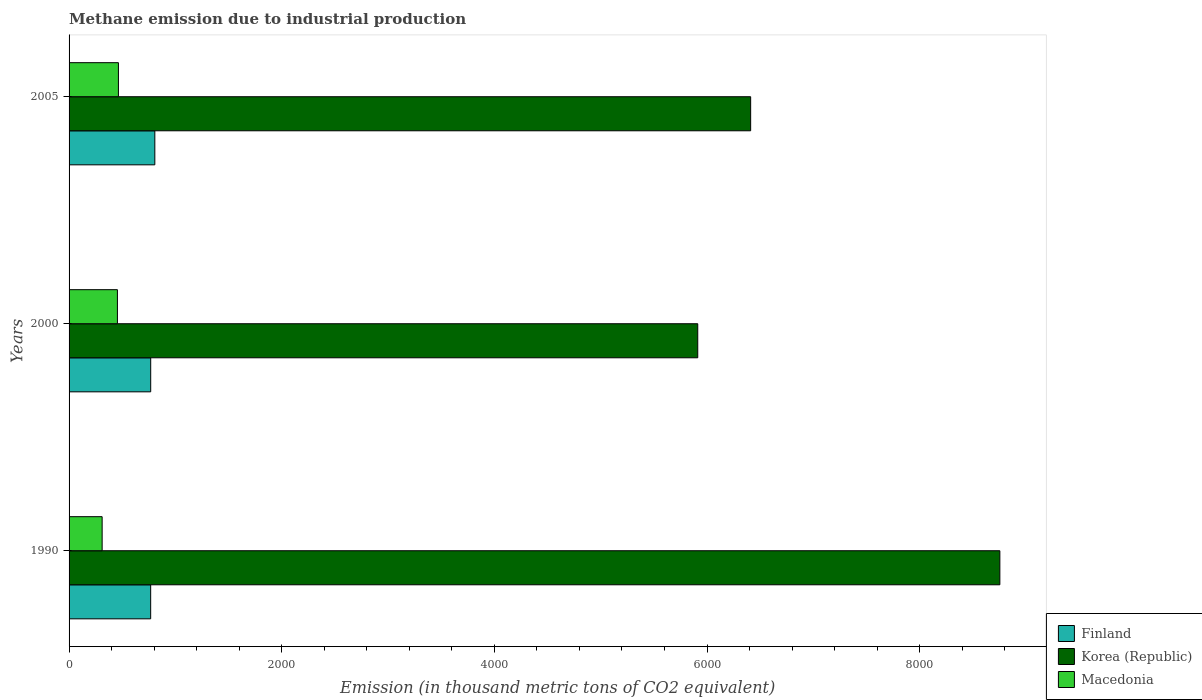How many different coloured bars are there?
Offer a very short reply. 3. Are the number of bars per tick equal to the number of legend labels?
Keep it short and to the point. Yes. Are the number of bars on each tick of the Y-axis equal?
Give a very brief answer. Yes. What is the label of the 3rd group of bars from the top?
Make the answer very short. 1990. In how many cases, is the number of bars for a given year not equal to the number of legend labels?
Offer a terse response. 0. What is the amount of methane emitted in Macedonia in 2005?
Offer a very short reply. 464.2. Across all years, what is the maximum amount of methane emitted in Macedonia?
Make the answer very short. 464.2. Across all years, what is the minimum amount of methane emitted in Korea (Republic)?
Give a very brief answer. 5912.8. What is the total amount of methane emitted in Korea (Republic) in the graph?
Provide a succinct answer. 2.11e+04. What is the difference between the amount of methane emitted in Finland in 2000 and that in 2005?
Give a very brief answer. -38.8. What is the difference between the amount of methane emitted in Macedonia in 1990 and the amount of methane emitted in Korea (Republic) in 2000?
Your answer should be very brief. -5601.8. What is the average amount of methane emitted in Finland per year?
Offer a very short reply. 780.63. In the year 2000, what is the difference between the amount of methane emitted in Korea (Republic) and amount of methane emitted in Finland?
Provide a succinct answer. 5145. What is the ratio of the amount of methane emitted in Finland in 1990 to that in 2005?
Provide a succinct answer. 0.95. Is the amount of methane emitted in Korea (Republic) in 2000 less than that in 2005?
Make the answer very short. Yes. What is the difference between the highest and the second highest amount of methane emitted in Korea (Republic)?
Ensure brevity in your answer.  2343.8. What is the difference between the highest and the lowest amount of methane emitted in Finland?
Ensure brevity in your answer.  39.1. How many bars are there?
Offer a very short reply. 9. Are all the bars in the graph horizontal?
Ensure brevity in your answer.  Yes. How many years are there in the graph?
Make the answer very short. 3. Does the graph contain grids?
Your answer should be compact. No. How many legend labels are there?
Make the answer very short. 3. What is the title of the graph?
Keep it short and to the point. Methane emission due to industrial production. What is the label or title of the X-axis?
Your answer should be compact. Emission (in thousand metric tons of CO2 equivalent). What is the Emission (in thousand metric tons of CO2 equivalent) of Finland in 1990?
Ensure brevity in your answer.  767.5. What is the Emission (in thousand metric tons of CO2 equivalent) of Korea (Republic) in 1990?
Your answer should be compact. 8754.2. What is the Emission (in thousand metric tons of CO2 equivalent) in Macedonia in 1990?
Make the answer very short. 311. What is the Emission (in thousand metric tons of CO2 equivalent) in Finland in 2000?
Provide a short and direct response. 767.8. What is the Emission (in thousand metric tons of CO2 equivalent) of Korea (Republic) in 2000?
Your response must be concise. 5912.8. What is the Emission (in thousand metric tons of CO2 equivalent) in Macedonia in 2000?
Your answer should be compact. 454.8. What is the Emission (in thousand metric tons of CO2 equivalent) in Finland in 2005?
Keep it short and to the point. 806.6. What is the Emission (in thousand metric tons of CO2 equivalent) of Korea (Republic) in 2005?
Provide a short and direct response. 6410.4. What is the Emission (in thousand metric tons of CO2 equivalent) in Macedonia in 2005?
Your answer should be very brief. 464.2. Across all years, what is the maximum Emission (in thousand metric tons of CO2 equivalent) of Finland?
Your response must be concise. 806.6. Across all years, what is the maximum Emission (in thousand metric tons of CO2 equivalent) in Korea (Republic)?
Your answer should be very brief. 8754.2. Across all years, what is the maximum Emission (in thousand metric tons of CO2 equivalent) of Macedonia?
Make the answer very short. 464.2. Across all years, what is the minimum Emission (in thousand metric tons of CO2 equivalent) in Finland?
Make the answer very short. 767.5. Across all years, what is the minimum Emission (in thousand metric tons of CO2 equivalent) of Korea (Republic)?
Your response must be concise. 5912.8. Across all years, what is the minimum Emission (in thousand metric tons of CO2 equivalent) of Macedonia?
Give a very brief answer. 311. What is the total Emission (in thousand metric tons of CO2 equivalent) in Finland in the graph?
Your answer should be very brief. 2341.9. What is the total Emission (in thousand metric tons of CO2 equivalent) in Korea (Republic) in the graph?
Offer a terse response. 2.11e+04. What is the total Emission (in thousand metric tons of CO2 equivalent) of Macedonia in the graph?
Give a very brief answer. 1230. What is the difference between the Emission (in thousand metric tons of CO2 equivalent) of Korea (Republic) in 1990 and that in 2000?
Your answer should be compact. 2841.4. What is the difference between the Emission (in thousand metric tons of CO2 equivalent) in Macedonia in 1990 and that in 2000?
Keep it short and to the point. -143.8. What is the difference between the Emission (in thousand metric tons of CO2 equivalent) of Finland in 1990 and that in 2005?
Give a very brief answer. -39.1. What is the difference between the Emission (in thousand metric tons of CO2 equivalent) of Korea (Republic) in 1990 and that in 2005?
Your response must be concise. 2343.8. What is the difference between the Emission (in thousand metric tons of CO2 equivalent) in Macedonia in 1990 and that in 2005?
Your answer should be very brief. -153.2. What is the difference between the Emission (in thousand metric tons of CO2 equivalent) in Finland in 2000 and that in 2005?
Make the answer very short. -38.8. What is the difference between the Emission (in thousand metric tons of CO2 equivalent) of Korea (Republic) in 2000 and that in 2005?
Make the answer very short. -497.6. What is the difference between the Emission (in thousand metric tons of CO2 equivalent) of Macedonia in 2000 and that in 2005?
Give a very brief answer. -9.4. What is the difference between the Emission (in thousand metric tons of CO2 equivalent) of Finland in 1990 and the Emission (in thousand metric tons of CO2 equivalent) of Korea (Republic) in 2000?
Keep it short and to the point. -5145.3. What is the difference between the Emission (in thousand metric tons of CO2 equivalent) in Finland in 1990 and the Emission (in thousand metric tons of CO2 equivalent) in Macedonia in 2000?
Your answer should be very brief. 312.7. What is the difference between the Emission (in thousand metric tons of CO2 equivalent) in Korea (Republic) in 1990 and the Emission (in thousand metric tons of CO2 equivalent) in Macedonia in 2000?
Make the answer very short. 8299.4. What is the difference between the Emission (in thousand metric tons of CO2 equivalent) of Finland in 1990 and the Emission (in thousand metric tons of CO2 equivalent) of Korea (Republic) in 2005?
Give a very brief answer. -5642.9. What is the difference between the Emission (in thousand metric tons of CO2 equivalent) in Finland in 1990 and the Emission (in thousand metric tons of CO2 equivalent) in Macedonia in 2005?
Provide a short and direct response. 303.3. What is the difference between the Emission (in thousand metric tons of CO2 equivalent) in Korea (Republic) in 1990 and the Emission (in thousand metric tons of CO2 equivalent) in Macedonia in 2005?
Your answer should be very brief. 8290. What is the difference between the Emission (in thousand metric tons of CO2 equivalent) of Finland in 2000 and the Emission (in thousand metric tons of CO2 equivalent) of Korea (Republic) in 2005?
Provide a succinct answer. -5642.6. What is the difference between the Emission (in thousand metric tons of CO2 equivalent) in Finland in 2000 and the Emission (in thousand metric tons of CO2 equivalent) in Macedonia in 2005?
Your response must be concise. 303.6. What is the difference between the Emission (in thousand metric tons of CO2 equivalent) in Korea (Republic) in 2000 and the Emission (in thousand metric tons of CO2 equivalent) in Macedonia in 2005?
Your answer should be compact. 5448.6. What is the average Emission (in thousand metric tons of CO2 equivalent) in Finland per year?
Provide a succinct answer. 780.63. What is the average Emission (in thousand metric tons of CO2 equivalent) in Korea (Republic) per year?
Your answer should be compact. 7025.8. What is the average Emission (in thousand metric tons of CO2 equivalent) in Macedonia per year?
Provide a succinct answer. 410. In the year 1990, what is the difference between the Emission (in thousand metric tons of CO2 equivalent) of Finland and Emission (in thousand metric tons of CO2 equivalent) of Korea (Republic)?
Give a very brief answer. -7986.7. In the year 1990, what is the difference between the Emission (in thousand metric tons of CO2 equivalent) in Finland and Emission (in thousand metric tons of CO2 equivalent) in Macedonia?
Give a very brief answer. 456.5. In the year 1990, what is the difference between the Emission (in thousand metric tons of CO2 equivalent) in Korea (Republic) and Emission (in thousand metric tons of CO2 equivalent) in Macedonia?
Ensure brevity in your answer.  8443.2. In the year 2000, what is the difference between the Emission (in thousand metric tons of CO2 equivalent) in Finland and Emission (in thousand metric tons of CO2 equivalent) in Korea (Republic)?
Offer a terse response. -5145. In the year 2000, what is the difference between the Emission (in thousand metric tons of CO2 equivalent) of Finland and Emission (in thousand metric tons of CO2 equivalent) of Macedonia?
Your response must be concise. 313. In the year 2000, what is the difference between the Emission (in thousand metric tons of CO2 equivalent) in Korea (Republic) and Emission (in thousand metric tons of CO2 equivalent) in Macedonia?
Your answer should be compact. 5458. In the year 2005, what is the difference between the Emission (in thousand metric tons of CO2 equivalent) in Finland and Emission (in thousand metric tons of CO2 equivalent) in Korea (Republic)?
Your response must be concise. -5603.8. In the year 2005, what is the difference between the Emission (in thousand metric tons of CO2 equivalent) of Finland and Emission (in thousand metric tons of CO2 equivalent) of Macedonia?
Give a very brief answer. 342.4. In the year 2005, what is the difference between the Emission (in thousand metric tons of CO2 equivalent) in Korea (Republic) and Emission (in thousand metric tons of CO2 equivalent) in Macedonia?
Keep it short and to the point. 5946.2. What is the ratio of the Emission (in thousand metric tons of CO2 equivalent) of Korea (Republic) in 1990 to that in 2000?
Make the answer very short. 1.48. What is the ratio of the Emission (in thousand metric tons of CO2 equivalent) of Macedonia in 1990 to that in 2000?
Provide a succinct answer. 0.68. What is the ratio of the Emission (in thousand metric tons of CO2 equivalent) of Finland in 1990 to that in 2005?
Give a very brief answer. 0.95. What is the ratio of the Emission (in thousand metric tons of CO2 equivalent) in Korea (Republic) in 1990 to that in 2005?
Offer a very short reply. 1.37. What is the ratio of the Emission (in thousand metric tons of CO2 equivalent) in Macedonia in 1990 to that in 2005?
Keep it short and to the point. 0.67. What is the ratio of the Emission (in thousand metric tons of CO2 equivalent) in Finland in 2000 to that in 2005?
Offer a very short reply. 0.95. What is the ratio of the Emission (in thousand metric tons of CO2 equivalent) in Korea (Republic) in 2000 to that in 2005?
Provide a succinct answer. 0.92. What is the ratio of the Emission (in thousand metric tons of CO2 equivalent) in Macedonia in 2000 to that in 2005?
Offer a very short reply. 0.98. What is the difference between the highest and the second highest Emission (in thousand metric tons of CO2 equivalent) of Finland?
Ensure brevity in your answer.  38.8. What is the difference between the highest and the second highest Emission (in thousand metric tons of CO2 equivalent) in Korea (Republic)?
Make the answer very short. 2343.8. What is the difference between the highest and the lowest Emission (in thousand metric tons of CO2 equivalent) of Finland?
Give a very brief answer. 39.1. What is the difference between the highest and the lowest Emission (in thousand metric tons of CO2 equivalent) of Korea (Republic)?
Provide a succinct answer. 2841.4. What is the difference between the highest and the lowest Emission (in thousand metric tons of CO2 equivalent) of Macedonia?
Provide a short and direct response. 153.2. 